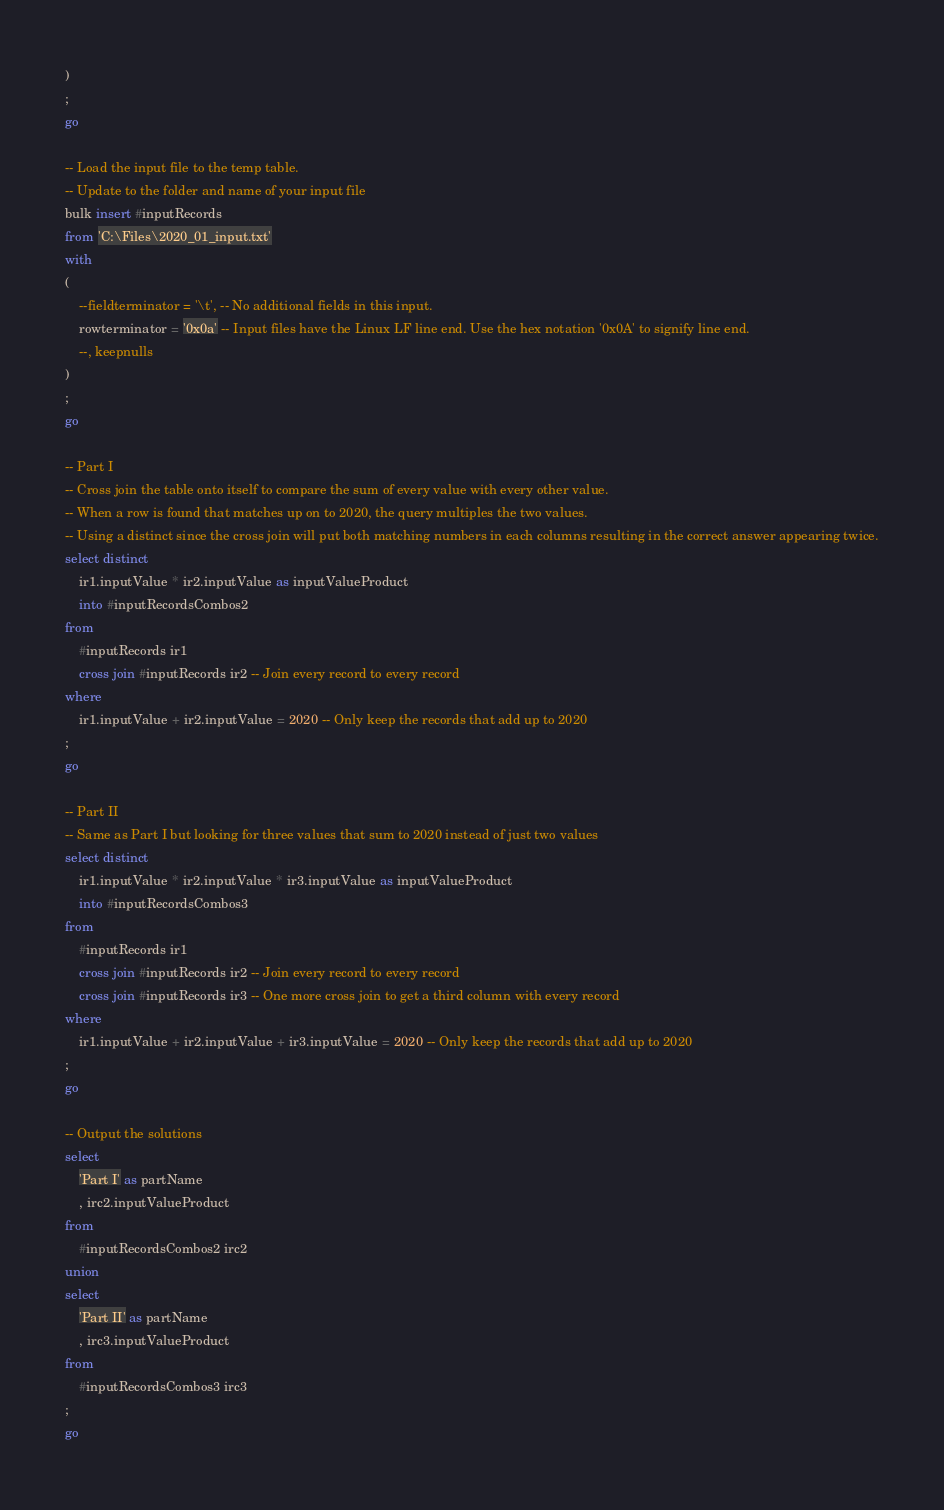Convert code to text. <code><loc_0><loc_0><loc_500><loc_500><_SQL_>)
;
go

-- Load the input file to the temp table.
-- Update to the folder and name of your input file
bulk insert #inputRecords
from 'C:\Files\2020_01_input.txt'
with
(
	--fieldterminator = '\t', -- No additional fields in this input.
	rowterminator = '0x0a' -- Input files have the Linux LF line end. Use the hex notation '0x0A' to signify line end.
	--, keepnulls
)
;
go

-- Part I
-- Cross join the table onto itself to compare the sum of every value with every other value.
-- When a row is found that matches up on to 2020, the query multiples the two values.
-- Using a distinct since the cross join will put both matching numbers in each columns resulting in the correct answer appearing twice.
select distinct
	ir1.inputValue * ir2.inputValue as inputValueProduct
	into #inputRecordsCombos2
from
	#inputRecords ir1
	cross join #inputRecords ir2 -- Join every record to every record
where
	ir1.inputValue + ir2.inputValue = 2020 -- Only keep the records that add up to 2020
;
go

-- Part II
-- Same as Part I but looking for three values that sum to 2020 instead of just two values
select distinct
	ir1.inputValue * ir2.inputValue * ir3.inputValue as inputValueProduct
	into #inputRecordsCombos3
from
	#inputRecords ir1
	cross join #inputRecords ir2 -- Join every record to every record
	cross join #inputRecords ir3 -- One more cross join to get a third column with every record
where
	ir1.inputValue + ir2.inputValue + ir3.inputValue = 2020 -- Only keep the records that add up to 2020
;
go

-- Output the solutions
select
	'Part I' as partName
	, irc2.inputValueProduct
from
	#inputRecordsCombos2 irc2
union
select
	'Part II' as partName
	, irc3.inputValueProduct
from
	#inputRecordsCombos3 irc3
;
go</code> 